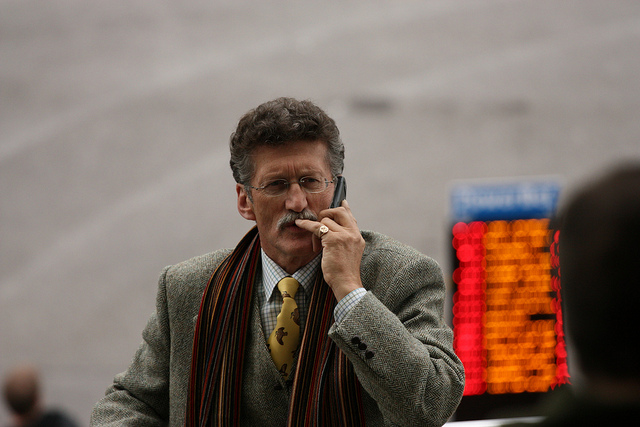<image>What do you think this man is thinking? I don't know what the man is thinking. What do you think this man is thinking? I am not sure what this man is thinking. It can be any of the given options. 